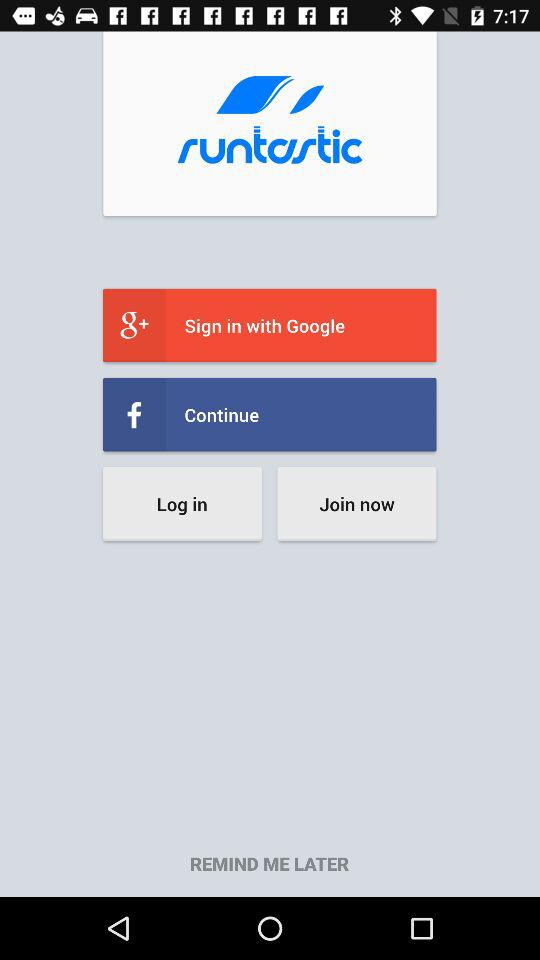What is the name of the application? The name of the application is "runtastic". 